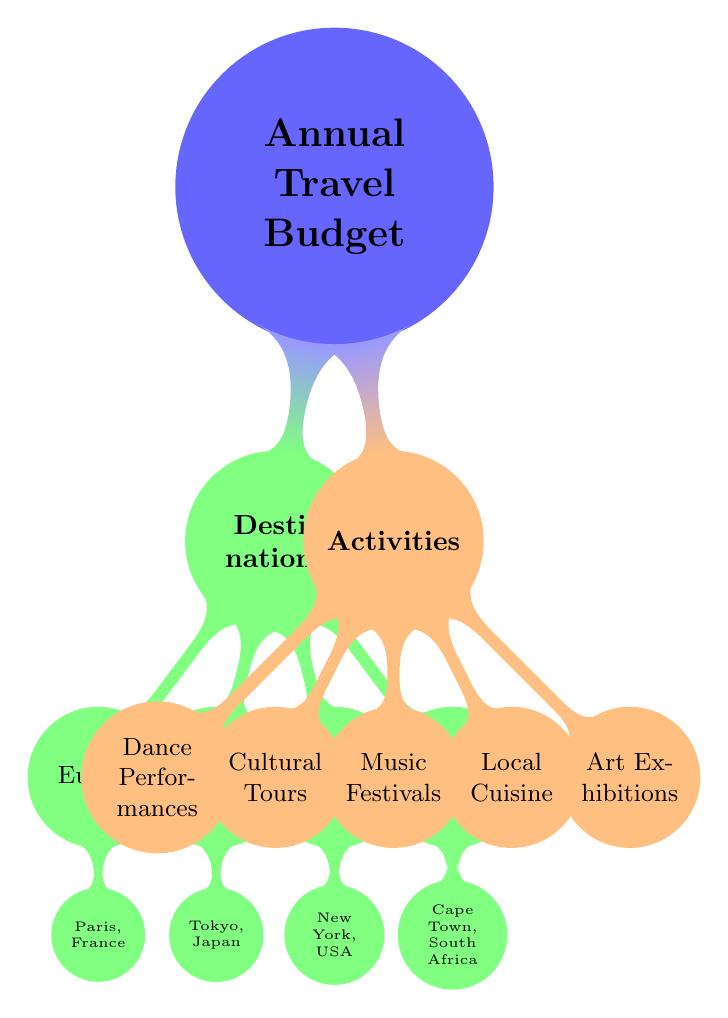What are the four main destinations listed in the diagram? The diagram lists Europe, Asia, North America, and Africa as the main destinations under the "Destinations" category, with each destination branching out into specific cities.
Answer: Europe, Asia, North America, Africa How many activities are categorized under the "Activities" section? The diagram details five activities listed under the "Activities" category: Dance Performances, Cultural Tours, Music Festivals, Local Cuisine, and Art Exhibitions, thus totaling five activities.
Answer: 5 Which destination corresponds to "Cape Town, South Africa"? "Cape Town, South Africa" is the city associated with the African destination in the diagram, which is a child node under the "Africa" parent node.
Answer: Africa What is the relationship between the "Dance Performances" and "Paris, France"? "Dance Performances" is listed under the "Activities" section, while "Paris, France" is a child node under the "Europe" destination. Thus, they are interconnected as performances that can be experienced in Paris, making it a destination for cultural events like dance.
Answer: Activity and Destination Which continent has a specific city node in the diagram? The diagram includes a specific city node for each continent mentioned; "New York, USA" is the only city node listed under "North America," highlighting it as a distinct hub in this region.
Answer: North America 